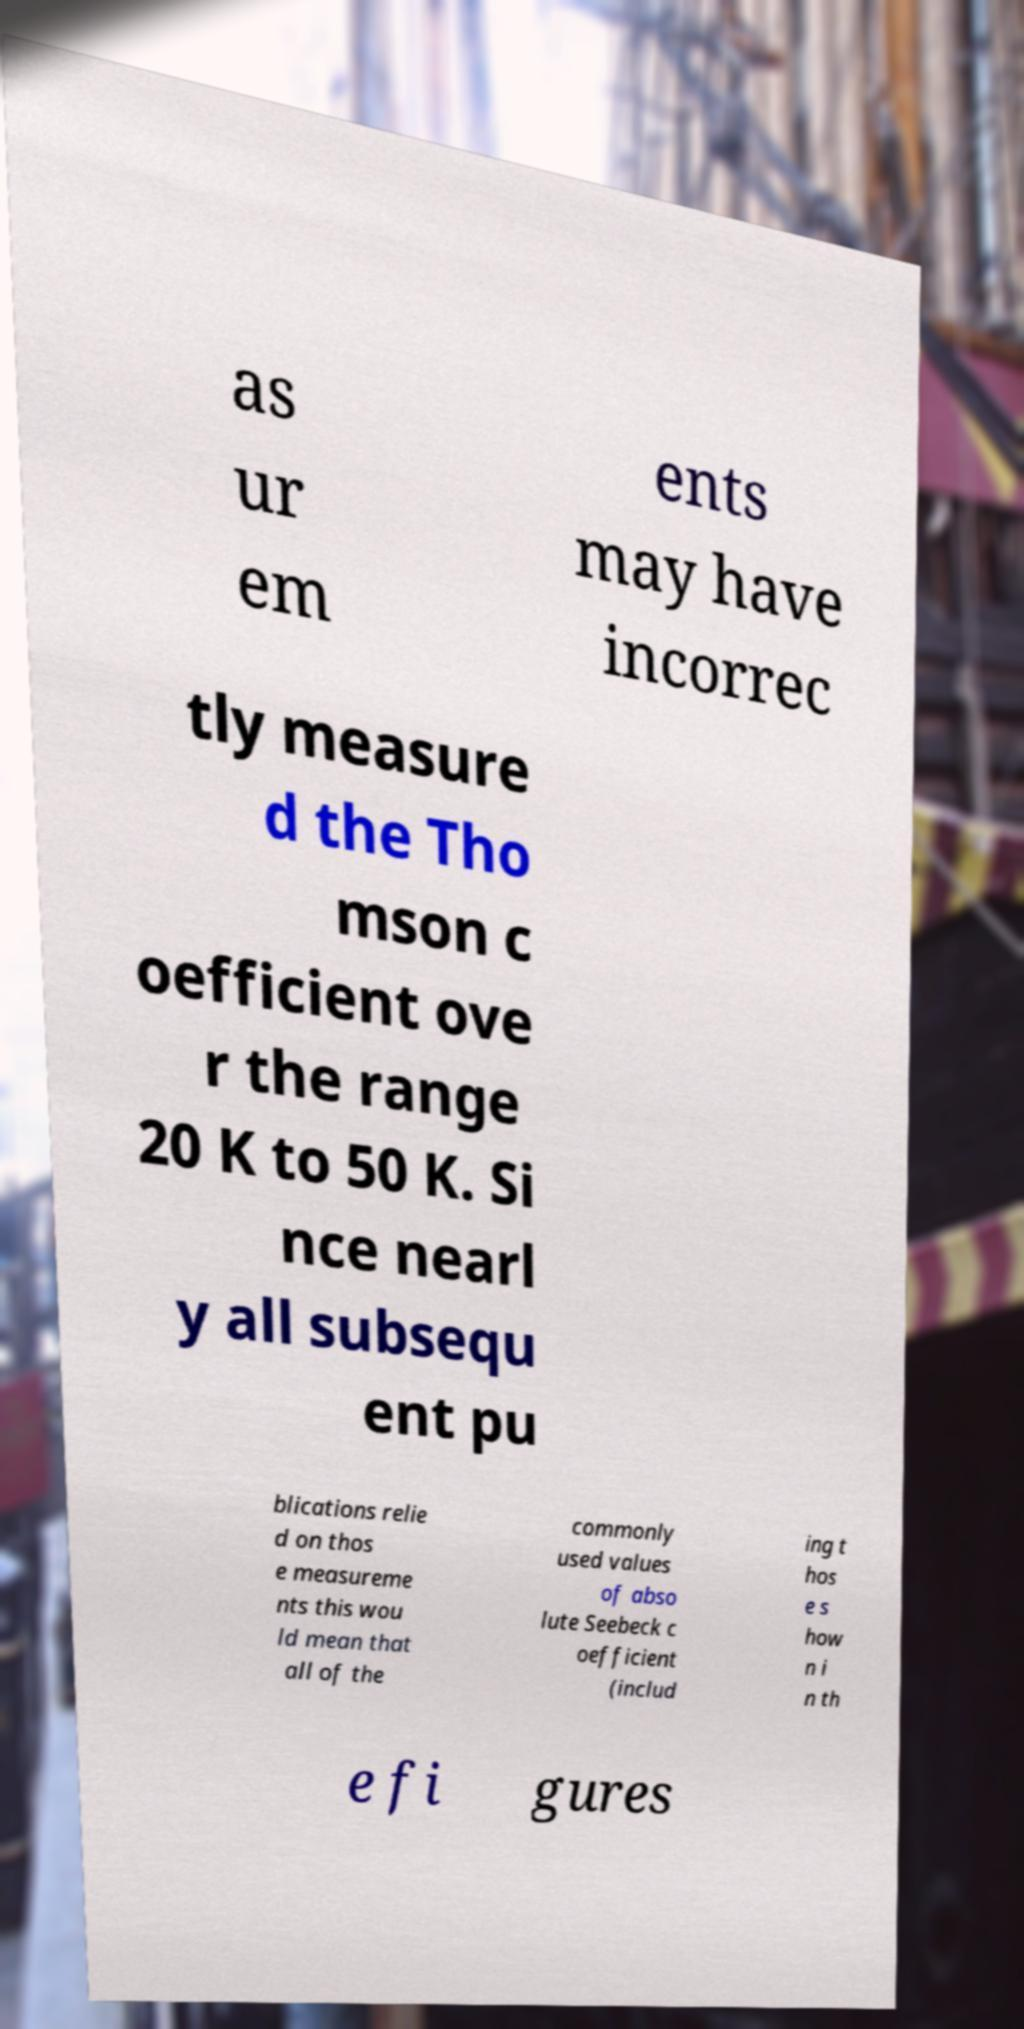Could you assist in decoding the text presented in this image and type it out clearly? as ur em ents may have incorrec tly measure d the Tho mson c oefficient ove r the range 20 K to 50 K. Si nce nearl y all subsequ ent pu blications relie d on thos e measureme nts this wou ld mean that all of the commonly used values of abso lute Seebeck c oefficient (includ ing t hos e s how n i n th e fi gures 